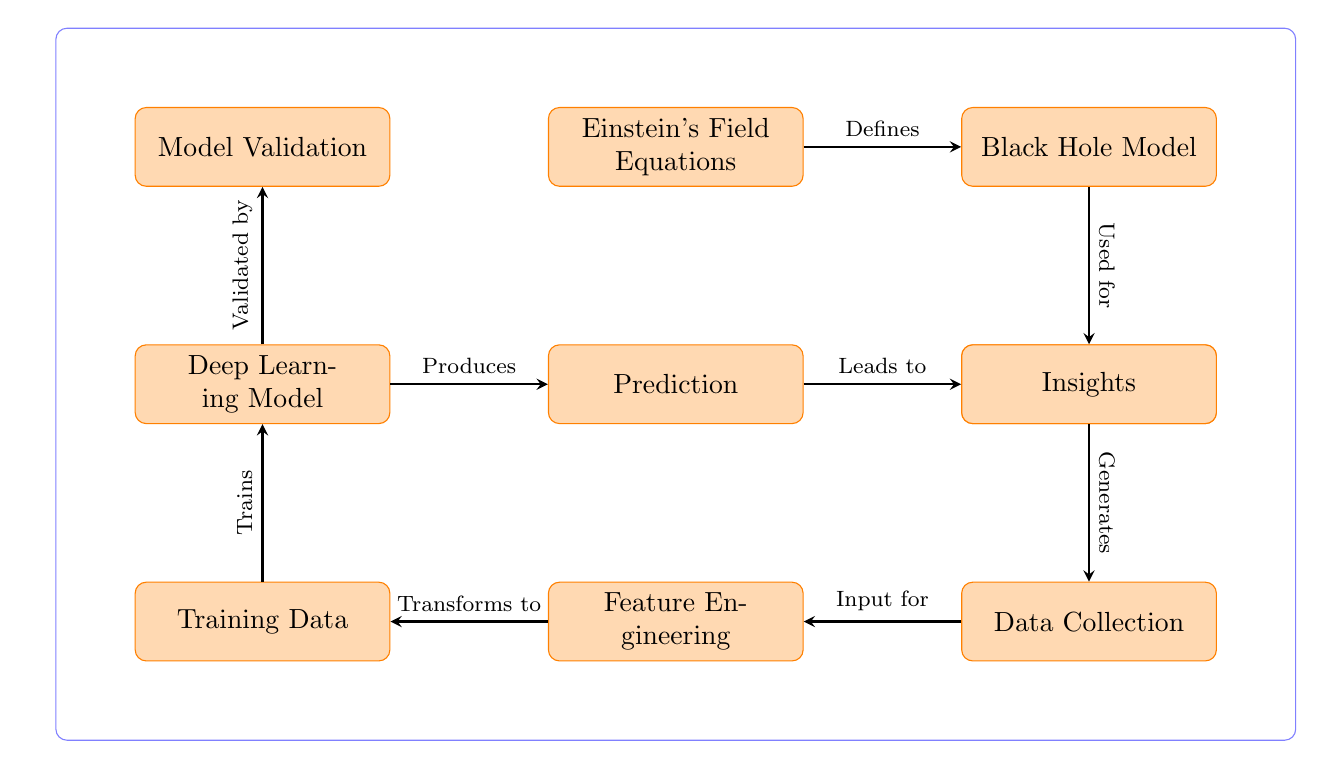What are the first two nodes in the diagram? The first two nodes in the diagram are "Einstein's Field Equations" and "Black Hole Model." They appear in a sequential order, with "Einstein's Field Equations" positioned to the left of "Black Hole Model."
Answer: Einstein's Field Equations, Black Hole Model What does the "Deep Learning Model" produce? The "Deep Learning Model" node points to the "Prediction" node, indicating that it produces predictions based on the training process that has been completed.
Answer: Prediction How many arrows are there in the diagram? Counting the directed arrows that connect different nodes in the diagram, there are a total of eight arrows. Each arrow represents a flow of information from one process to another.
Answer: 8 What is the relationship between "Validation" and "Deep Learning Model"? The relationship is indicated by an arrow pointing from "Deep Learning Model" to "Model Validation," showing that the model is validated after it is trained.
Answer: Validated by Which node leads to "Insights"? The "Prediction" node leads to the "Insights" node, as shown by the arrow pointing from "Prediction" to "Insights," indicating that predictions provide insights.
Answer: Prediction 